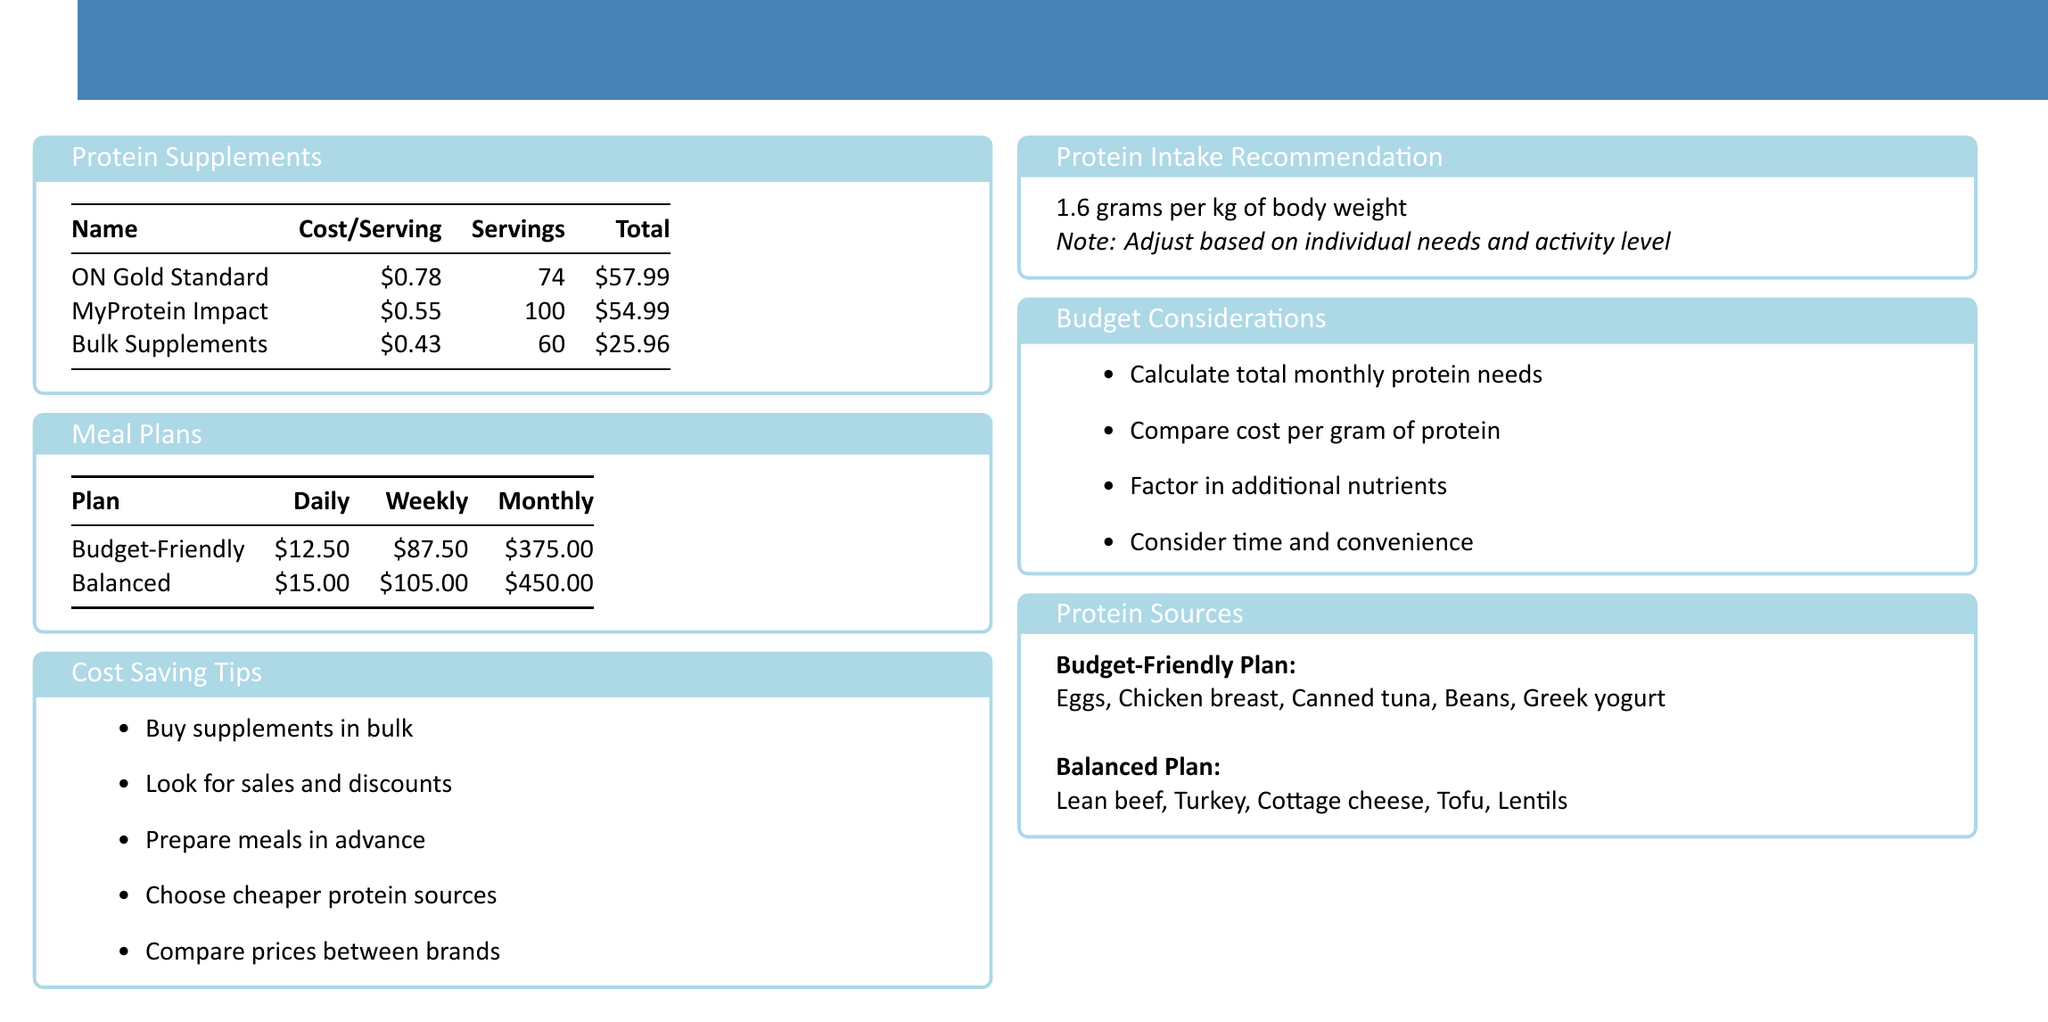what is the cost per serving of ON Gold Standard? The cost per serving of ON Gold Standard is listed in the table under Protein Supplements.
Answer: $0.78 how many servings does MyProtein Impact provide? The number of servings for MyProtein Impact is indicated in the Protein Supplements section of the document.
Answer: 100 what is the total cost of Bulk Supplements? The total cost of Bulk Supplements can be found in the summary table under Protein Supplements.
Answer: $25.96 what is the weekly cost of the Balanced meal plan? The weekly cost of the Balanced meal plan is mentioned in the Meal Plans section.
Answer: $105.00 which protein supplement has the lowest cost per serving? The document lists the costs per serving for each supplement, allowing for a comparison.
Answer: Bulk Supplements what are two protein sources recommended in the Budget-Friendly Plan? The document lists several protein sources for each plan, including Budget-Friendly.
Answer: Eggs, Chicken breast what is the protein intake recommendation for an individual? The recommendation is provided in the Protein Intake Recommendation section of the document.
Answer: 1.6 grams per kg of body weight what is one of the cost-saving tips mentioned in the document? The document provides a list of cost-saving tips for purchasing supplements and meal planning.
Answer: Buy supplements in bulk how much is the monthly cost of the Budget-Friendly meal plan? The monthly cost is specified in the Meal Plans table of the document.
Answer: $375.00 